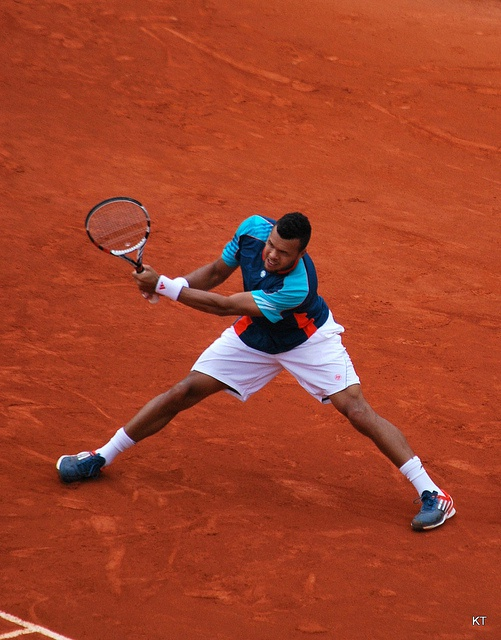Describe the objects in this image and their specific colors. I can see people in brown, black, maroon, and lavender tones and tennis racket in brown and black tones in this image. 